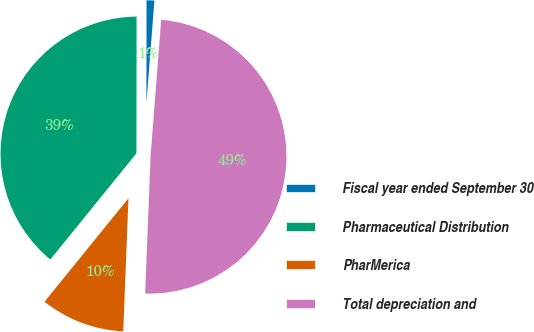Convert chart. <chart><loc_0><loc_0><loc_500><loc_500><pie_chart><fcel>Fiscal year ended September 30<fcel>Pharmaceutical Distribution<fcel>PharMerica<fcel>Total depreciation and<nl><fcel>1.22%<fcel>39.17%<fcel>10.22%<fcel>49.39%<nl></chart> 